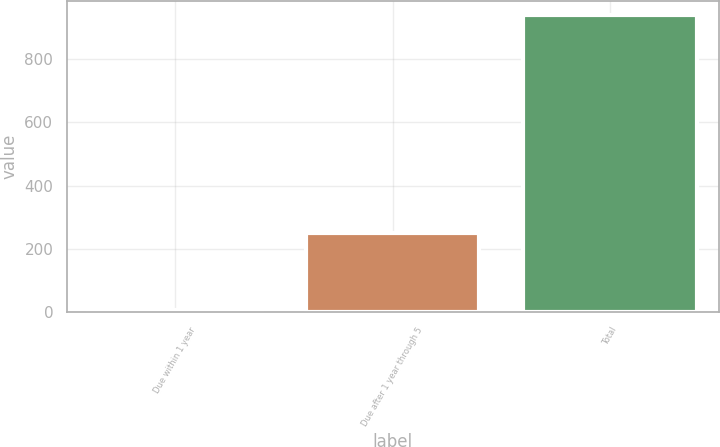Convert chart. <chart><loc_0><loc_0><loc_500><loc_500><bar_chart><fcel>Due within 1 year<fcel>Due after 1 year through 5<fcel>Total<nl><fcel>8<fcel>251<fcel>937<nl></chart> 